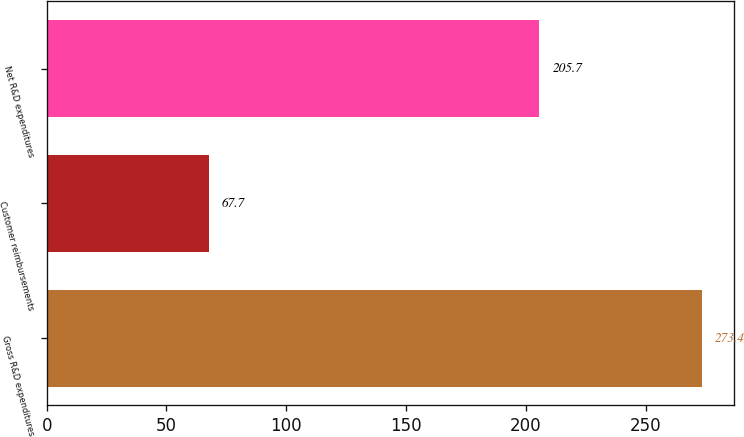Convert chart. <chart><loc_0><loc_0><loc_500><loc_500><bar_chart><fcel>Gross R&D expenditures<fcel>Customer reimbursements<fcel>Net R&D expenditures<nl><fcel>273.4<fcel>67.7<fcel>205.7<nl></chart> 